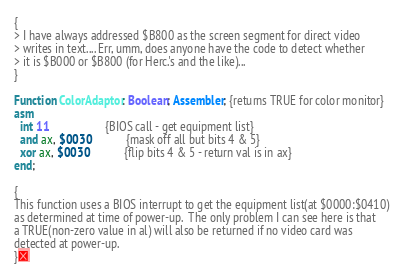<code> <loc_0><loc_0><loc_500><loc_500><_Pascal_>{
> I have always addressed $B800 as the screen segment for direct video
> writes in text.... Err, umm, does anyone have the code to detect whether
> it is $B000 or $B800 (for Herc.'s and the like)...
}

Function ColorAdaptor: Boolean; Assembler; {returns TRUE for color monitor}
asm
  int 11                   {BIOS call - get equipment list}
  and ax, $0030            {mask off all but bits 4 & 5}
  xor ax, $0030            {flip bits 4 & 5 - return val is in ax}
end;

{
This function uses a BIOS interrupt to get the equipment list(at $0000:$0410)
as determined at time of power-up.  The only problem I can see here is that
a TRUE(non-zero value in al) will also be returned if no video card was
detected at power-up.
}</code> 